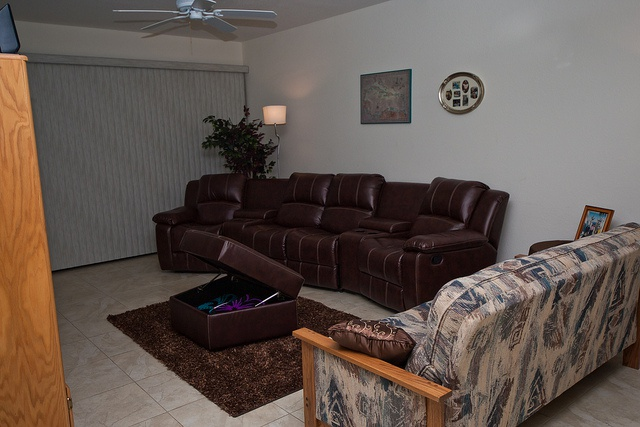Describe the objects in this image and their specific colors. I can see couch in black, gray, and maroon tones, couch in black and gray tones, suitcase in black, gray, and purple tones, and potted plant in black and gray tones in this image. 